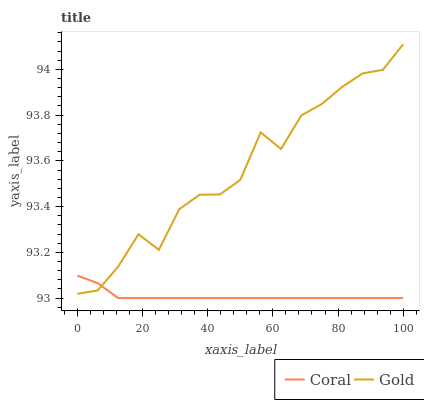Does Coral have the minimum area under the curve?
Answer yes or no. Yes. Does Gold have the maximum area under the curve?
Answer yes or no. Yes. Does Gold have the minimum area under the curve?
Answer yes or no. No. Is Coral the smoothest?
Answer yes or no. Yes. Is Gold the roughest?
Answer yes or no. Yes. Is Gold the smoothest?
Answer yes or no. No. Does Coral have the lowest value?
Answer yes or no. Yes. Does Gold have the lowest value?
Answer yes or no. No. Does Gold have the highest value?
Answer yes or no. Yes. Does Gold intersect Coral?
Answer yes or no. Yes. Is Gold less than Coral?
Answer yes or no. No. Is Gold greater than Coral?
Answer yes or no. No. 